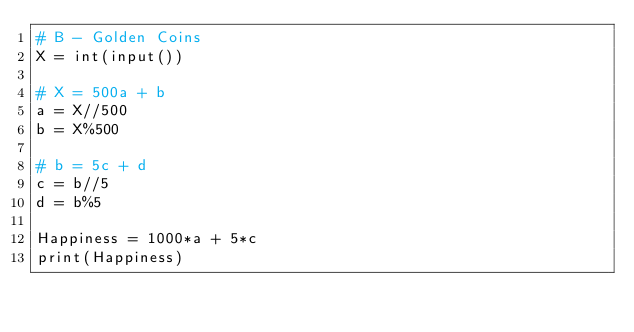Convert code to text. <code><loc_0><loc_0><loc_500><loc_500><_Python_># B - Golden Coins
X = int(input())

# X = 500a + b
a = X//500
b = X%500

# b = 5c + d
c = b//5
d = b%5

Happiness = 1000*a + 5*c
print(Happiness)</code> 